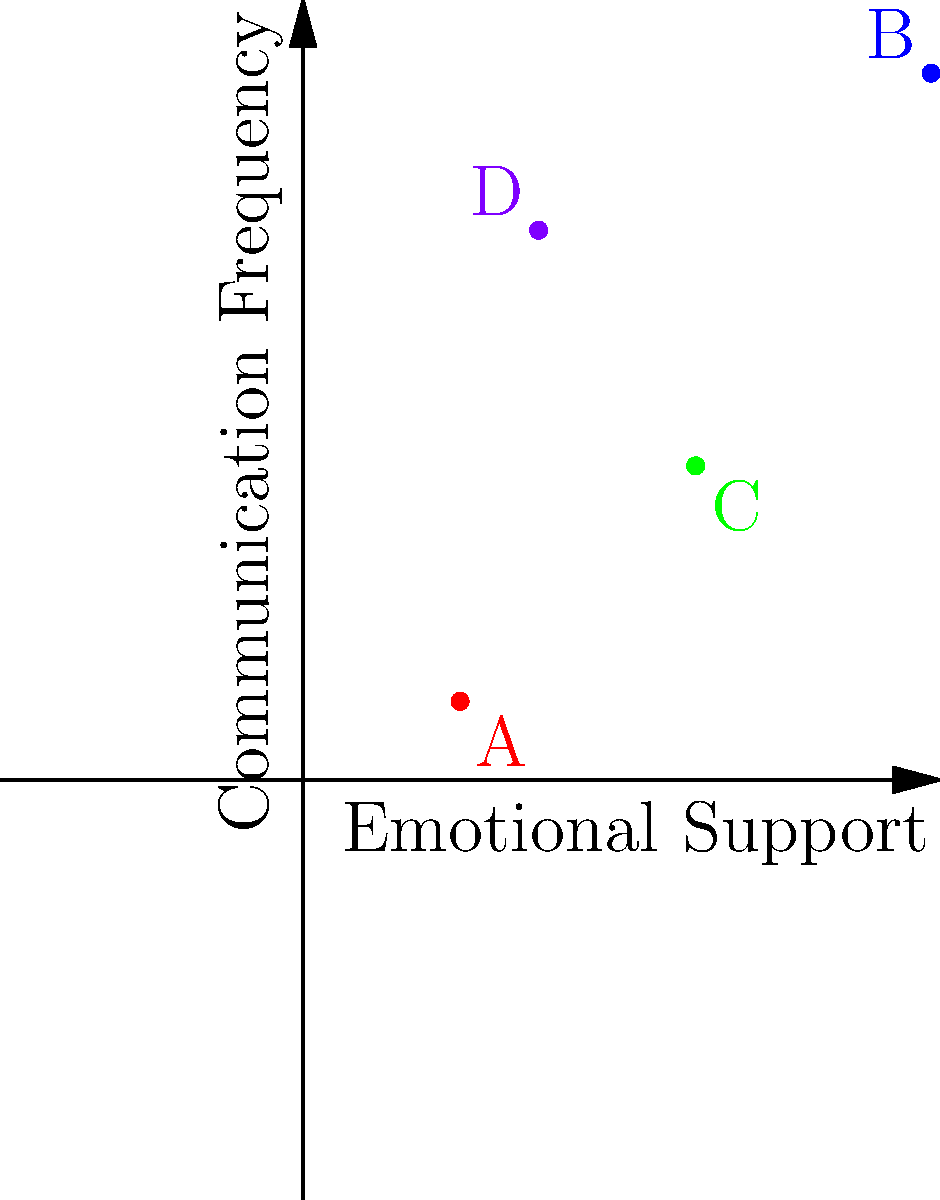In a family dynamics assessment, four family members (A, B, C, and D) are mapped on a 2D plane based on their emotional support (x-axis) and communication frequency (y-axis) with each other. Given the graph, which family member appears to have the highest level of emotional closeness with others, considering both dimensions? To determine the family member with the highest level of emotional closeness, we need to consider both dimensions:

1. Emotional Support (x-axis):
   A: 0.2, B: 0.8, C: 0.5, D: 0.3

2. Communication Frequency (y-axis):
   A: 0.1, B: 0.9, C: 0.4, D: 0.7

3. Emotional closeness is a combination of both factors. We can roughly estimate it by considering the position of each point relative to the origin (0,0).

4. Family member B (0.8, 0.9) is positioned furthest from the origin, indicating high levels of both emotional support and communication frequency.

5. Family member D (0.3, 0.7) has the second-highest position, followed by C (0.5, 0.4) and A (0.2, 0.1).

6. While D has higher communication frequency than C, C provides more emotional support. However, B outperforms both in both dimensions.

Therefore, family member B demonstrates the highest level of emotional closeness when considering both emotional support and communication frequency.
Answer: B 